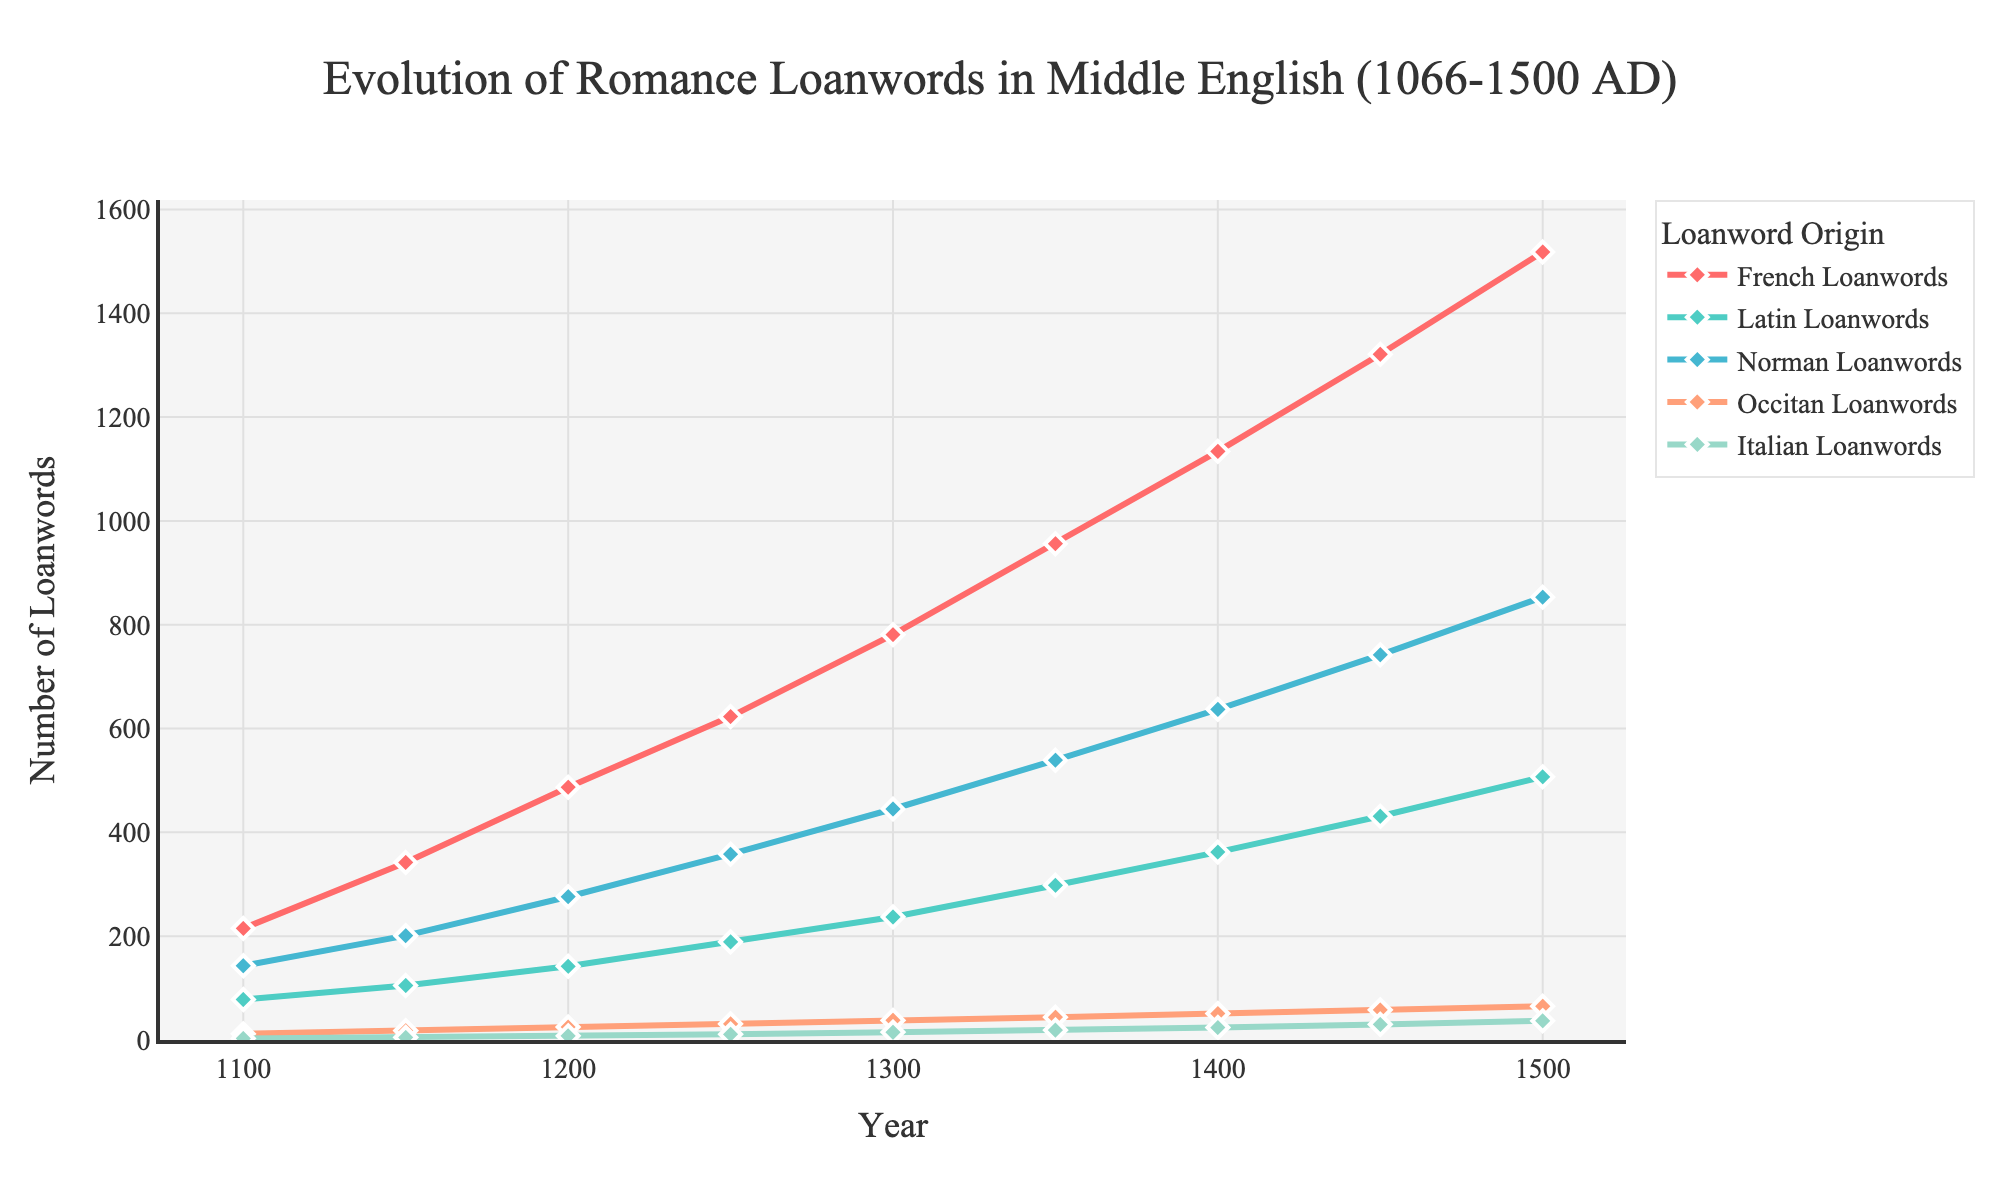What year did Italian Loanwords reach 30? According to the figure, Italian Loanwords reached 30 in 1450 AD, as shown by the intersection of the Italian Loanwords line and the value of 30 on the y-axis.
Answer: 1450 Which loanword origin had the highest number in 1300 AD? In 1300 AD, the plot shows that French Loanwords had the highest number compared to Latin, Norman, Occitan, and Italian Loanwords, as indicated by the highest point on the French Loanwords line.
Answer: French Loanwords How did the number of Norman Loanwords change from 1100 AD to 1150 AD? From 1100 AD to 1150 AD, the number of Norman Loanwords increased. The figure shows the number moving from 143 in 1100 AD to 201 in 1150 AD.
Answer: Increased Across the entire timeline, which loanword origin increased the most in absolute numbers? By comparing the differences from the initial to final values for all loanword origins, French Loanwords show the greatest increase, moving from 215 in 1100 AD to 1518 in 1500 AD.
Answer: French Loanwords What is the cumulative number of Latin and Occitan Loanwords in 1350 AD? In 1350 AD, Latin Loanwords are 298 and Occitan Loanwords are 44. Summing these values provides 298 + 44 = 342.
Answer: 342 Did the number of Norman Loanwords ever exceed 800? If so, when? Yes, the number of Norman Loanwords exceeded 800 in the year 1500 AD, as shown in the figure.
Answer: 1500 Which category experienced a faster rate of increase between 1400 AD and 1450 AD: French or Latin Loanwords? Within this period, French Loanwords increased from 1134 to 1321, a difference of 187. Latin Loanwords increased from 362 to 431, a difference of 69. French Loanwords had a faster rate of increase.
Answer: French Loanwords In which year did Latin Loanwords surpass 300? Observing the figure, Latin Loanwords reached and surpassed 300 in the year 1350 AD.
Answer: 1350 What is the average number of Occitan Loanwords over the entire period? Summing Occitan Loanwords across all years: 12 + 18 + 25 + 31 + 38 + 44 + 51 + 58 + 65 = 342. The period covers 9 years, so the average is 342 / 9 = 38.
Answer: 38 